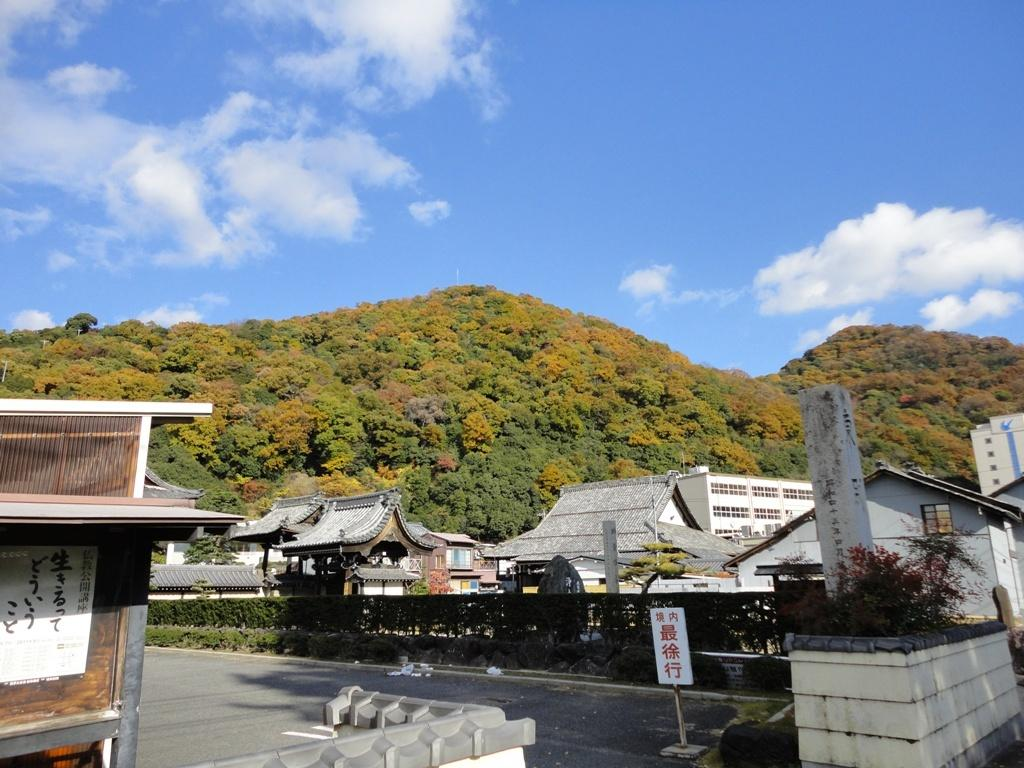What type of vegetation can be seen in the image? There are trees and plants in the image. What structures are present in the image? There are sheds and buildings in the image. What is on the road in the image? There is a board on the road in the image. What is visible in the sky at the top of the image? There are clouds in the sky at the top of the image. How many people are saying good-bye to each other in the image? There is no crowd or people saying good-bye in the image. What type of brick is used to build the sheds in the image? There is no mention of brick or the materials used to build the sheds in the image. 